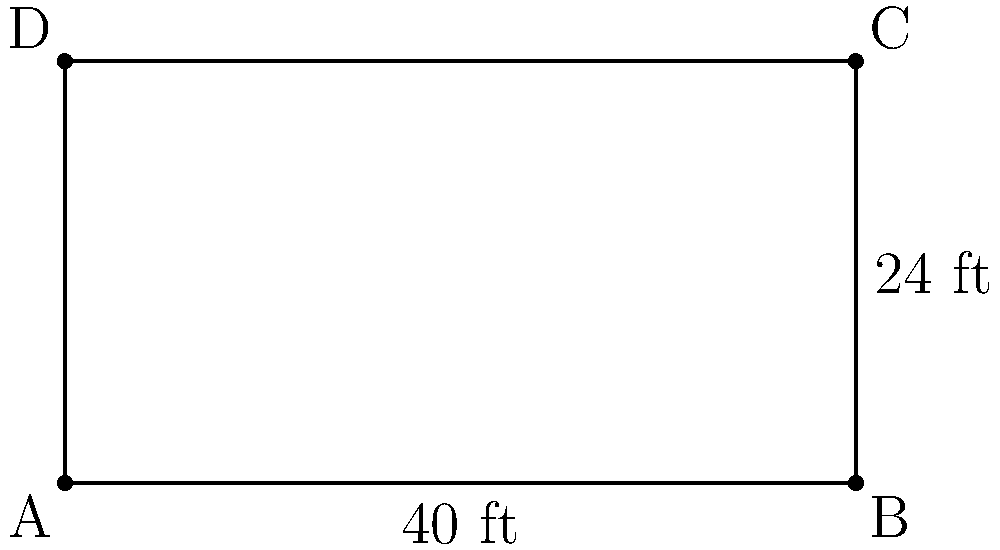As a conductor, you're overseeing the renovation of a rectangular orchestra pit. The pit measures 40 feet in length and 24 feet in width. What is the perimeter of the orchestra pit in feet? To find the perimeter of a rectangular orchestra pit, we need to follow these steps:

1. Identify the length and width of the rectangle:
   Length (l) = 40 feet
   Width (w) = 24 feet

2. Recall the formula for the perimeter of a rectangle:
   Perimeter = 2(length + width) or P = 2(l + w)

3. Substitute the known values into the formula:
   P = 2(40 + 24)

4. Perform the addition inside the parentheses:
   P = 2(64)

5. Multiply:
   P = 128

Therefore, the perimeter of the rectangular orchestra pit is 128 feet.
Answer: 128 feet 